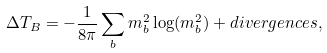Convert formula to latex. <formula><loc_0><loc_0><loc_500><loc_500>& \Delta T _ { B } = - \frac { 1 } { 8 \pi } \sum _ { b } m _ { b } ^ { 2 } \log ( m _ { b } ^ { 2 } ) + d i v e r g e n c e s ,</formula> 